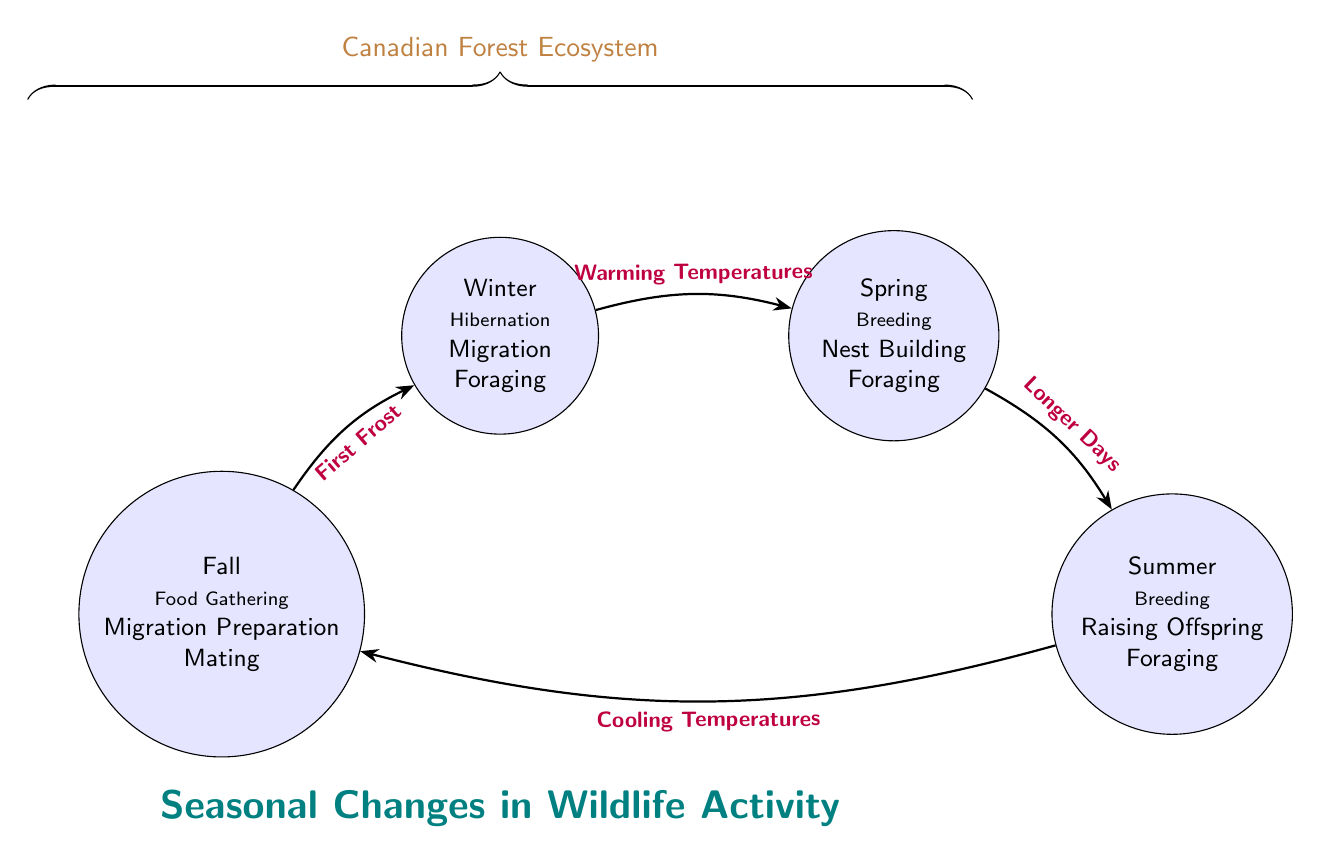What is the first state of the diagram? The first state listed in the diagram is "Winter," which is the initial position in the flow of seasonal changes.
Answer: Winter How many states are represented in the diagram? The diagram displays a total of four distinct states: Winter, Spring, Summer, and Fall.
Answer: 4 What action occurs in Spring? One of the actions listed for Spring is "Breeding," which highlights a significant activity for wildlife during this season.
Answer: Breeding What triggers the transition from Summer to Fall? The transition between the Summer and Fall states is prompted by "Cooling Temperatures," indicating a change in temperature that facilitates this shift.
Answer: Cooling Temperatures Which state follows Fall in the diagram? The state that follows Fall is Winter, as noted in the transition indicated by the first frost triggering this change.
Answer: Winter What action is associated with Winter? One of the actions associated with Winter is "Hibernation," showcasing how wildlife responds to the cold conditions of this season.
Answer: Hibernation What is the last state that follows after Spring? After Spring, the next state is Summer, transitioning due to the presence of longer days that influence wildlife activities.
Answer: Summer What action occurs just before migration in Fall? The action that precedes migration in Fall is "Food Gathering," reflecting how animals prepare for the upcoming winter.
Answer: Food Gathering What is the common theme of activities in Summer? The common theme of activities in Summer includes "Raising Offspring," which is crucial for wildlife during this peak activity season.
Answer: Raising Offspring 